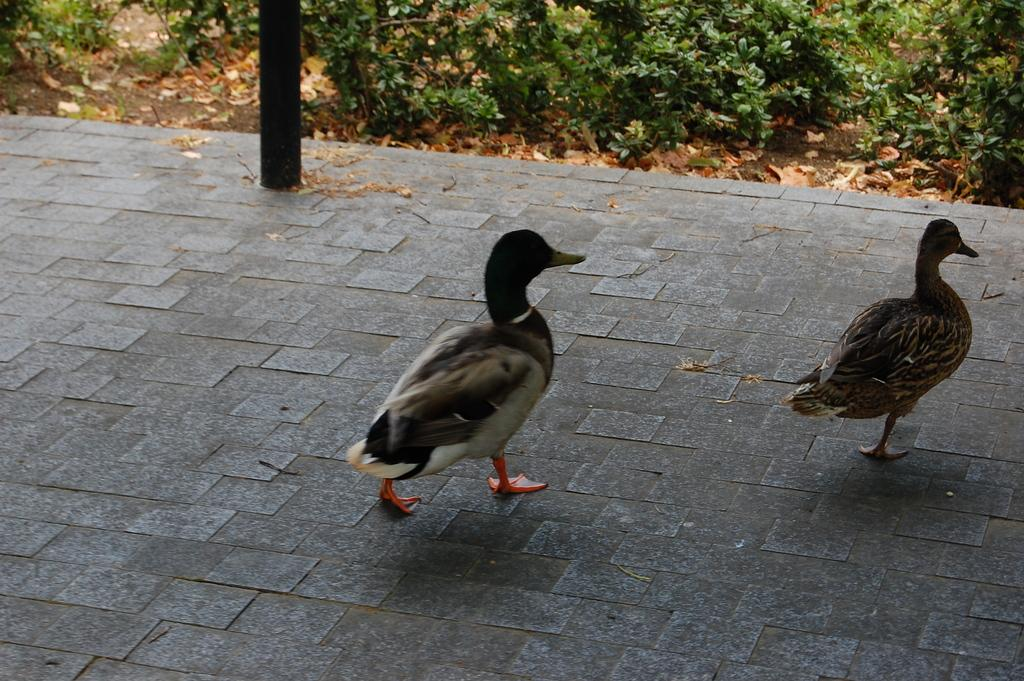How many birds are present in the image? There are two birds in the image. What colors can be seen on the birds? The birds have white, black, and brown colors. What type of vegetation is visible in the image? There are green plants in the image. What structure can be seen in the image? There is a pole in the image. What type of grain is being harvested by the birds in the image? There is no grain present in the image, and the birds are not shown harvesting anything. 